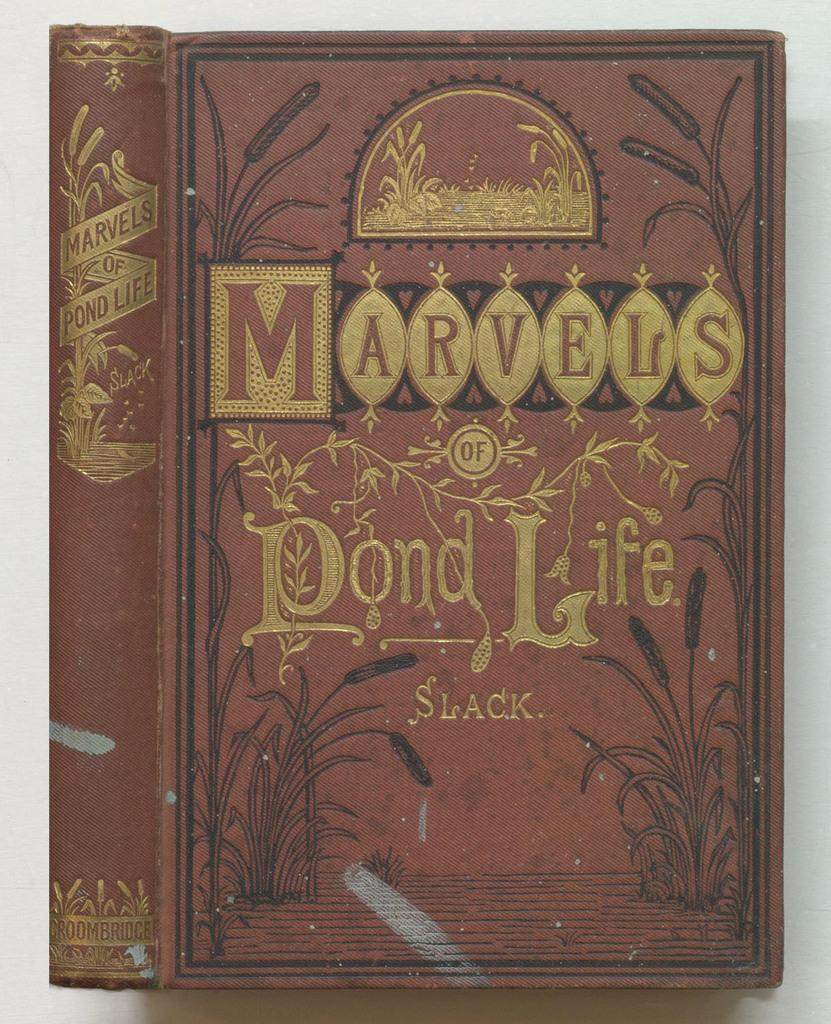<image>
Create a compact narrative representing the image presented. An old book a bout the marvels of pond life 